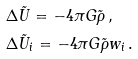<formula> <loc_0><loc_0><loc_500><loc_500>& \Delta \tilde { U } = - 4 \pi G \tilde { \rho } \, , & \\ & \Delta \tilde { U } _ { i } = - 4 \pi G \tilde { \rho } w _ { i } \, . &</formula> 